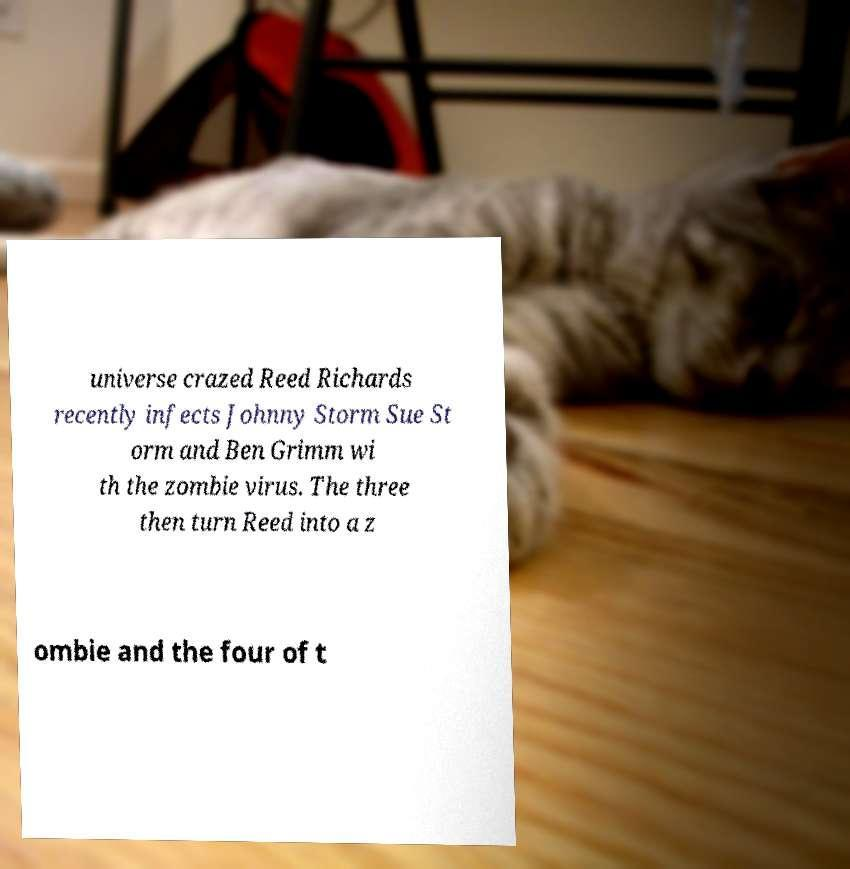Can you accurately transcribe the text from the provided image for me? universe crazed Reed Richards recently infects Johnny Storm Sue St orm and Ben Grimm wi th the zombie virus. The three then turn Reed into a z ombie and the four of t 